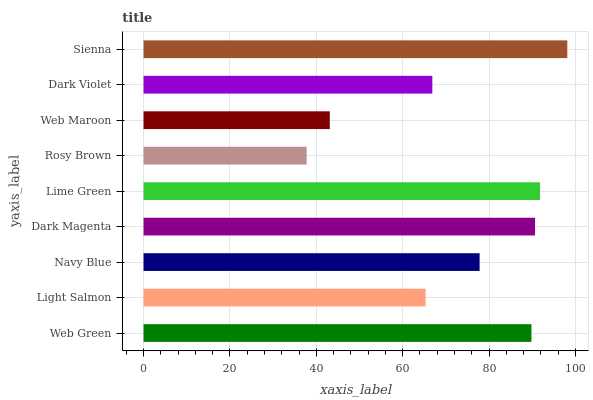Is Rosy Brown the minimum?
Answer yes or no. Yes. Is Sienna the maximum?
Answer yes or no. Yes. Is Light Salmon the minimum?
Answer yes or no. No. Is Light Salmon the maximum?
Answer yes or no. No. Is Web Green greater than Light Salmon?
Answer yes or no. Yes. Is Light Salmon less than Web Green?
Answer yes or no. Yes. Is Light Salmon greater than Web Green?
Answer yes or no. No. Is Web Green less than Light Salmon?
Answer yes or no. No. Is Navy Blue the high median?
Answer yes or no. Yes. Is Navy Blue the low median?
Answer yes or no. Yes. Is Dark Violet the high median?
Answer yes or no. No. Is Rosy Brown the low median?
Answer yes or no. No. 